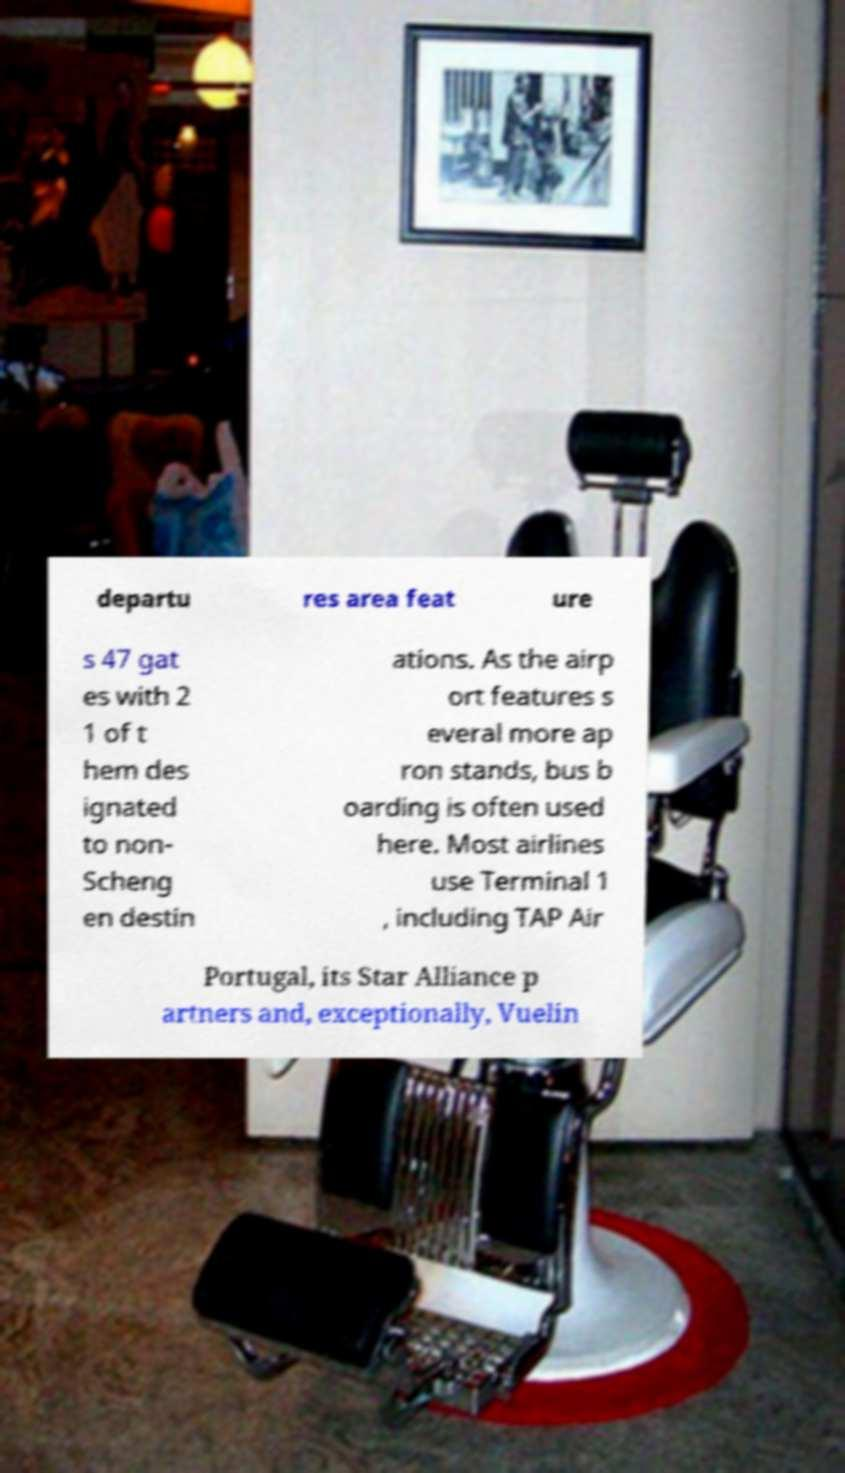For documentation purposes, I need the text within this image transcribed. Could you provide that? departu res area feat ure s 47 gat es with 2 1 of t hem des ignated to non- Scheng en destin ations. As the airp ort features s everal more ap ron stands, bus b oarding is often used here. Most airlines use Terminal 1 , including TAP Air Portugal, its Star Alliance p artners and, exceptionally, Vuelin 